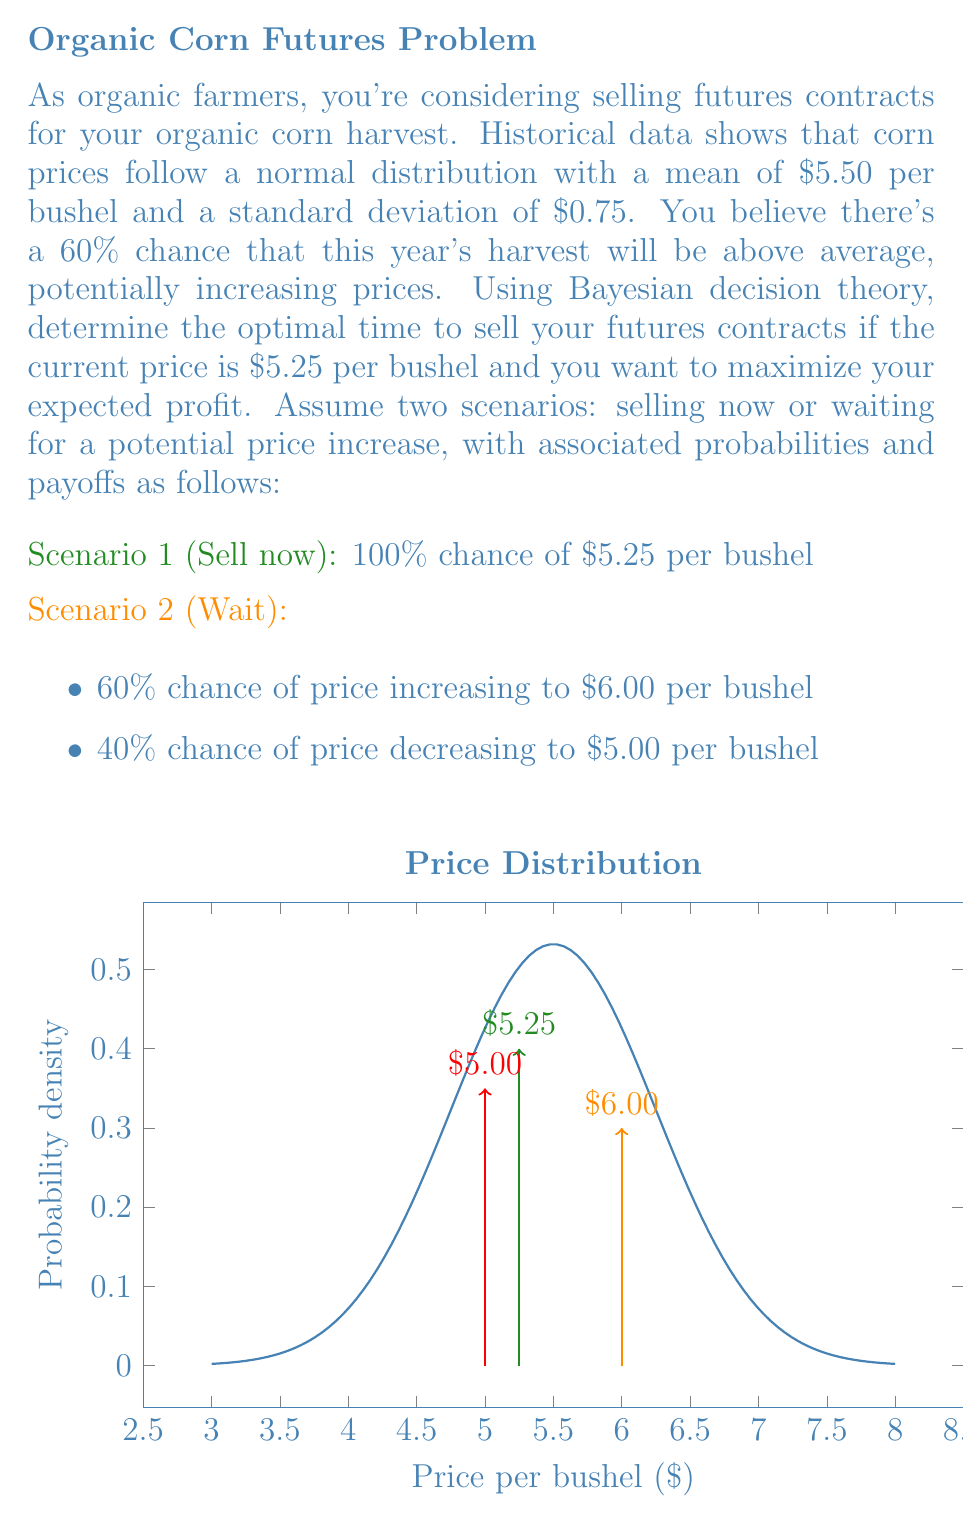Can you answer this question? To solve this problem using Bayesian decision theory, we need to calculate the expected value of each scenario and choose the one with the highest expected value. Let's go through this step-by-step:

1. Calculate the expected value of Scenario 1 (Sell now):
   $E(\text{Sell now}) = $5.25 \times 1.00 = $5.25$ per bushel

2. Calculate the expected value of Scenario 2 (Wait):
   $E(\text{Wait}) = ($6.00 \times 0.60) + ($5.00 \times 0.40)$
   $E(\text{Wait}) = $3.60 + $2.00 = $5.60$ per bushel

3. Compare the expected values:
   $E(\text{Wait}) > E(\text{Sell now})$
   $5.60 > 5.25$

4. Calculate the difference in expected value:
   $\text{Difference} = E(\text{Wait}) - E(\text{Sell now})$
   $\text{Difference} = $5.60 - $5.25 = $0.35$ per bushel

5. Apply Bayesian decision theory:
   The optimal decision is the one that maximizes expected value. In this case, waiting has a higher expected value than selling now.

6. Consider the risk:
   While waiting has a higher expected value, it also carries more risk. The farmers should consider their risk tolerance when making the final decision.

7. Conclusion:
   Based on Bayesian decision theory and the given probabilities, the optimal time to sell the futures contracts is to wait for a potential price increase, as it offers a higher expected profit of $0.35 per bushel compared to selling now.
Answer: Wait for a potential price increase. 